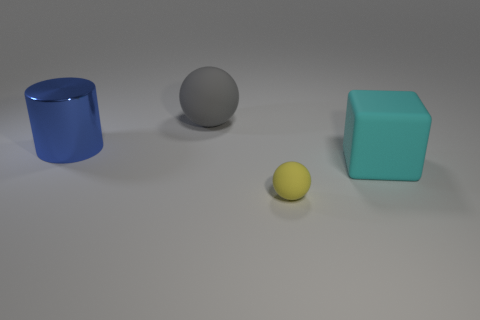Can you describe the sizes of the objects relative to each other? Certainly! The blue cylinder and the turquoise cube are approximately of the same size, which is the largest among the objects. The gray sphere is slightly smaller, while the yellow sphere is the smallest object in the scene. 